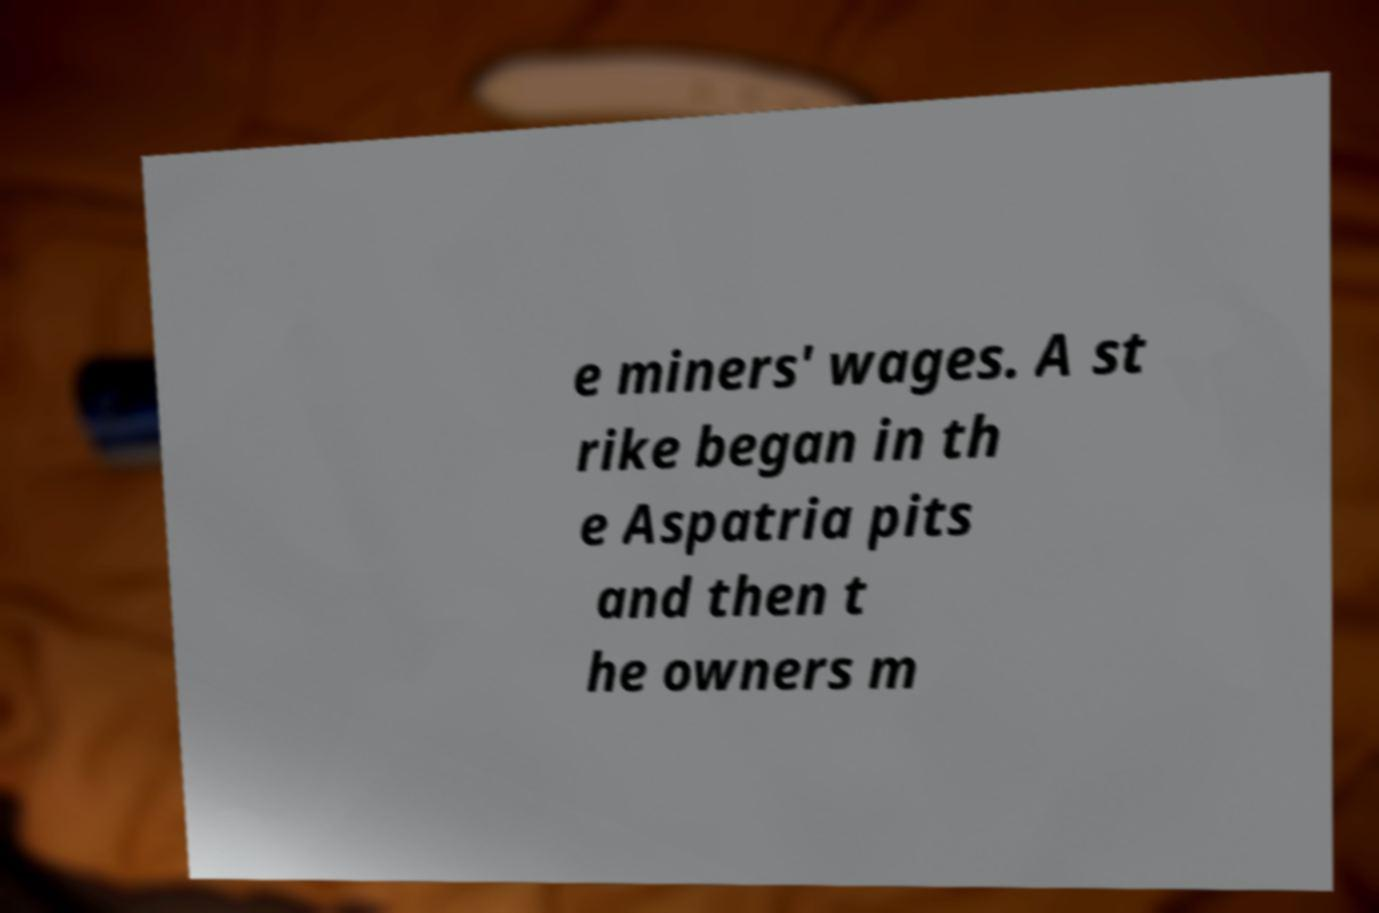Can you read and provide the text displayed in the image?This photo seems to have some interesting text. Can you extract and type it out for me? e miners' wages. A st rike began in th e Aspatria pits and then t he owners m 